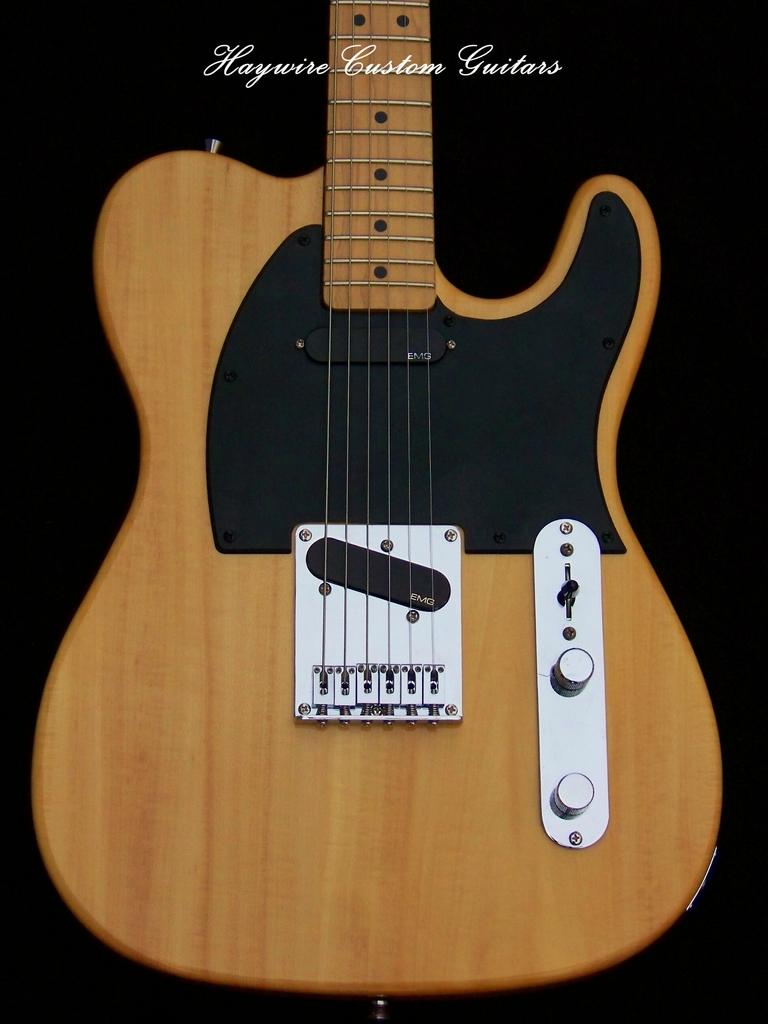What musical instrument is present in the image? The image contains a guitar. Can you see any yarn being used to play the guitar in the image? There is no yarn present in the image, and it is not being used to play the guitar. 